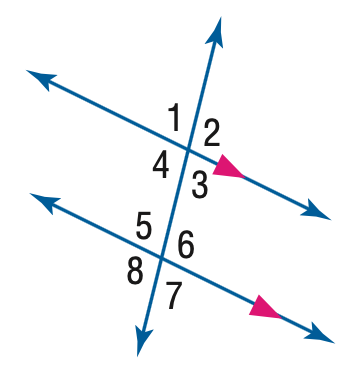Answer the mathemtical geometry problem and directly provide the correct option letter.
Question: In the figure, m \angle 4 = 101. Find the measure of \angle 5.
Choices: A: 69 B: 79 C: 89 D: 101 B 